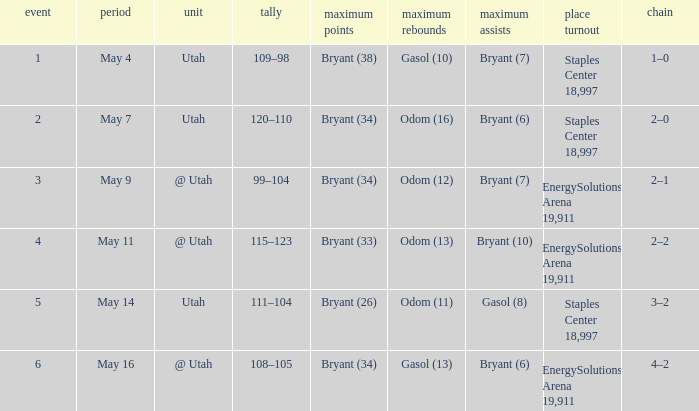What is the High rebounds with a High assists with bryant (7), and a Team of @ utah? Odom (12). 